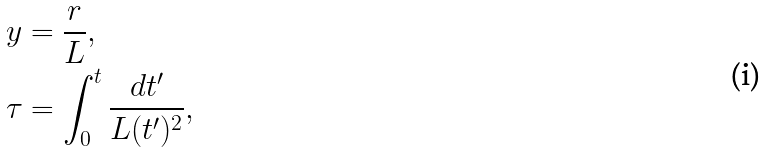Convert formula to latex. <formula><loc_0><loc_0><loc_500><loc_500>& y = \frac { r } { L } , \\ & \tau = \int ^ { t } _ { 0 } \frac { d t ^ { \prime } } { L ( t ^ { \prime } ) ^ { 2 } } ,</formula> 